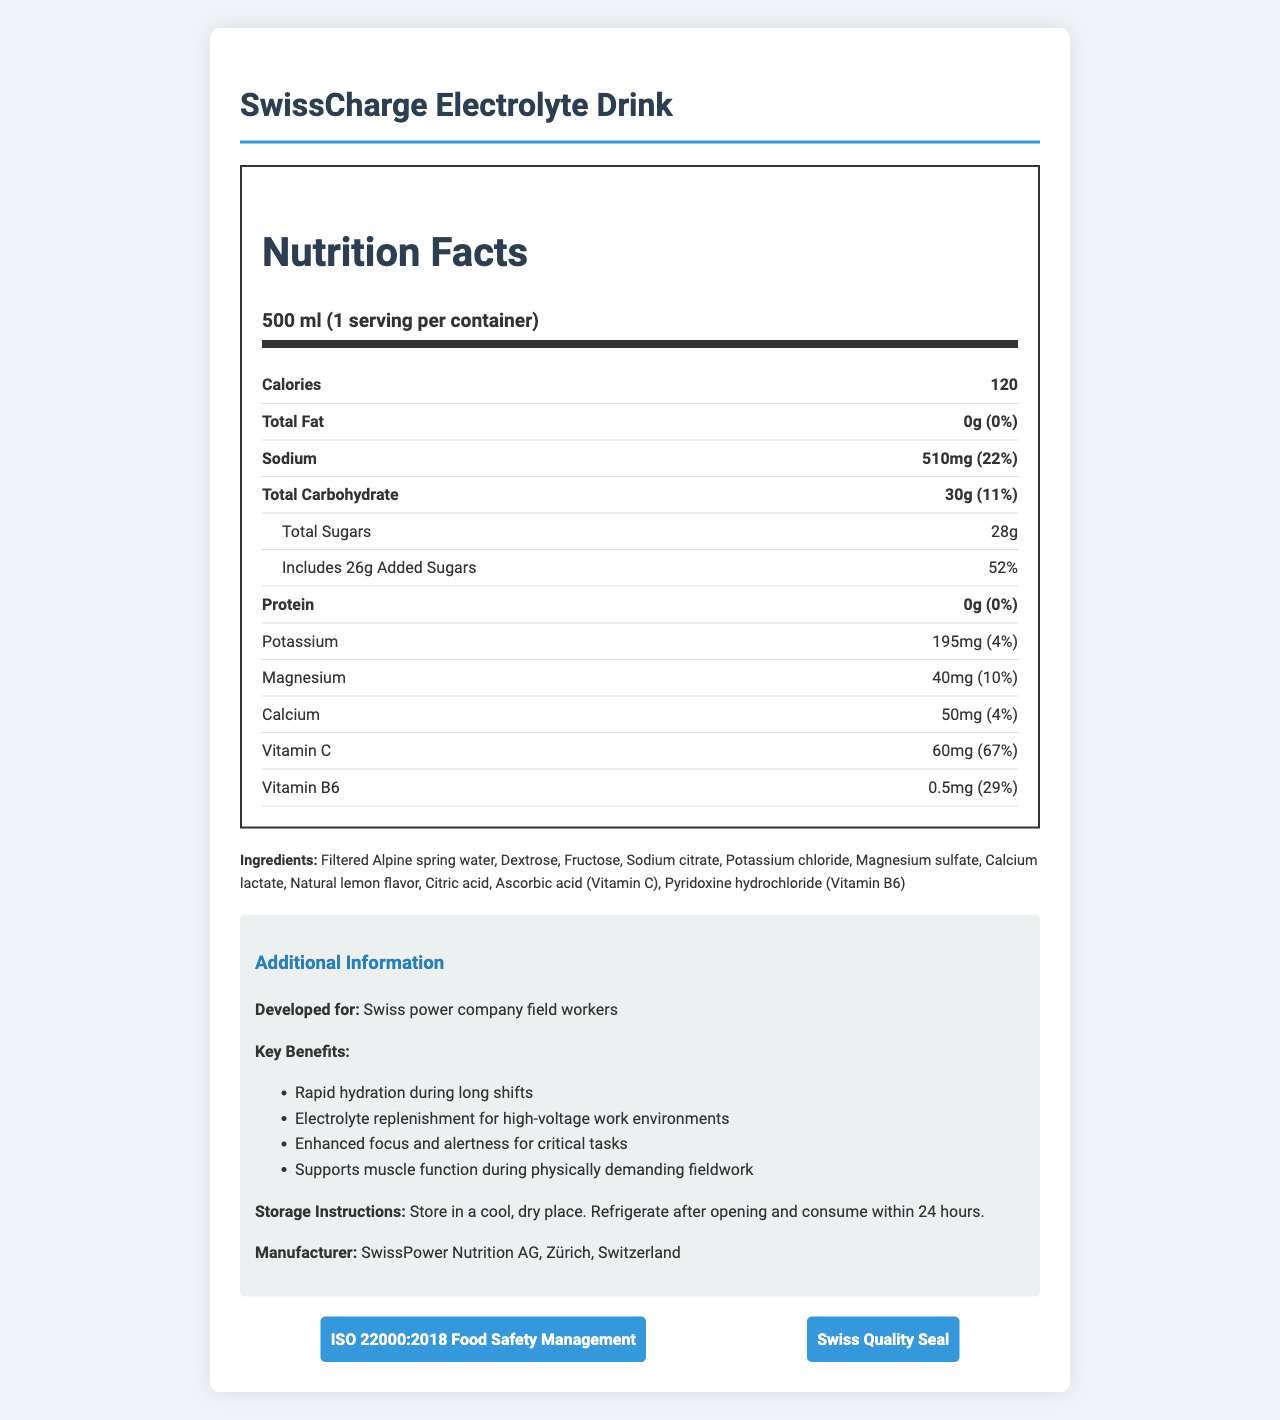What is the serving size for SwissCharge Electrolyte Drink? The document shows the serving size as "500 ml".
Answer: 500 ml How many servings are there per container of SwissCharge Electrolyte Drink? The document specifies that there is "1 serving per container".
Answer: 1 How much sodium is present in one serving of SwissCharge Electrolyte Drink? The sodium content is listed in the nutrition label as "510mg".
Answer: 510 mg Which ingredient is the main source of Vitamin C in SwissCharge Electrolyte Drink? The ingredients list includes "Ascorbic acid (Vitamin C)" as the source of Vitamin C.
Answer: Ascorbic acid What are the benefits of consuming SwissCharge Electrolyte Drink during physically demanding fieldwork? The document lists the key benefits under "Additional Information", including "Rapid hydration during long shifts", "Electrolyte replenishment for high-voltage work environments", "Enhanced focus and alertness for critical tasks", and "Supports muscle function during physically demanding fieldwork".
Answer: Rapid hydration, electrolyte replenishment, enhanced focus, supports muscle function How much protein does SwissCharge Electrolyte Drink contain? The nutrition label shows the protein amount as "0g".
Answer: 0g What percentage of the daily value of Vitamin C does one serving provide? The nutrition label shows that one serving provides "67%" of the daily value for Vitamin C.
Answer: 67% How much added sugars are there in one serving of SwissCharge Electrolyte Drink? The nutrition label indicates "Includes 26g Added Sugars".
Answer: 26g Which certification is mentioned on the document for ensuring food safety management? A. ISO 9001 B. ISO 22000:2018 C. Halal The document lists "ISO 22000:2018 Food Safety Management" under certifications.
Answer: B. ISO 22000:2018 What is the caloric content of one serving of SwissCharge Electrolyte Drink? The nutrition label shows the caloric content as "120".
Answer: 120 What ingredient is used to add a natural lemon flavor to SwissCharge Electrolyte Drink? The ingredients list includes "Natural lemon flavor".
Answer: Natural lemon flavor Is there any fat content present in SwissCharge Electrolyte Drink? Yes/No The nutrition label indicates "Total Fat: 0g".
Answer: No Summarize the main idea of the document. The document covers comprehensive nutritional content, ingredient list, key benefits aimed at field workers, as well as storage instructions and certifications for the SwissCharge Electrolyte Drink.
Answer: The document provides detailed nutritional information about the SwissCharge Electrolyte Drink, including ingredients, key benefits, and certifications. It highlights the product as designed for Swiss power company field workers, emphasizing benefits like rapid hydration, electrolyte replenishment, and enhanced focus and alertness. Who is the manufacturer of SwissCharge Electrolyte Drink? The manufacturer information is listed in the "Additional Information" section as "SwissPower Nutrition AG, Zürich, Switzerland".
Answer: SwissPower Nutrition AG, Zürich, Switzerland Can you determine the exact percentage of daily value for potassium in SwissCharge Electrolyte Drink? The nutrition label specifies the daily value for potassium as "4%".
Answer: 4% What is the storage instruction for SwissCharge Electrolyte Drink? The document lists storage instructions in the "Additional Information" section.
Answer: Store in a cool, dry place. Refrigerate after opening and consume within 24 hours. Does the document state the amount of caffeine in the SwissCharge Electrolyte Drink? The document does not provide any information regarding the caffeine content of the drink.
Answer: Not enough information 